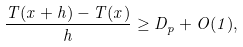<formula> <loc_0><loc_0><loc_500><loc_500>\frac { T ( x + h ) - T ( x ) } { h } \geq D _ { p } + O ( 1 ) ,</formula> 